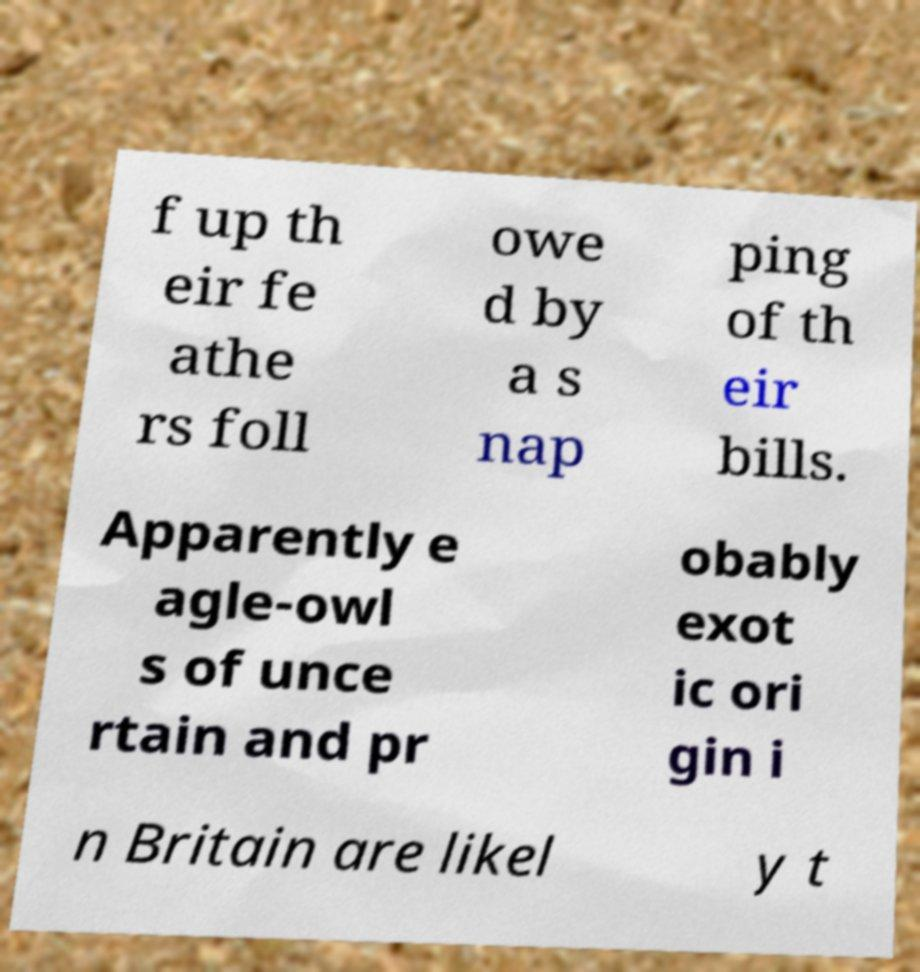Can you accurately transcribe the text from the provided image for me? f up th eir fe athe rs foll owe d by a s nap ping of th eir bills. Apparently e agle-owl s of unce rtain and pr obably exot ic ori gin i n Britain are likel y t 